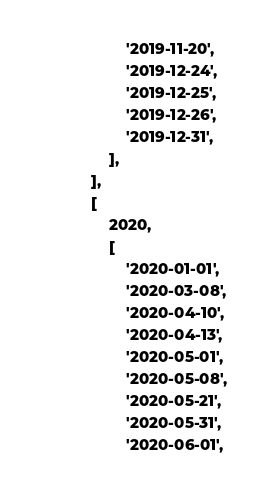Convert code to text. <code><loc_0><loc_0><loc_500><loc_500><_PHP_>                    '2019-11-20',
                    '2019-12-24',
                    '2019-12-25',
                    '2019-12-26',
                    '2019-12-31',
                ],
            ],
            [
                2020,
                [
                    '2020-01-01',
                    '2020-03-08',
                    '2020-04-10',
                    '2020-04-13',
                    '2020-05-01',
                    '2020-05-08',
                    '2020-05-21',
                    '2020-05-31',
                    '2020-06-01',</code> 